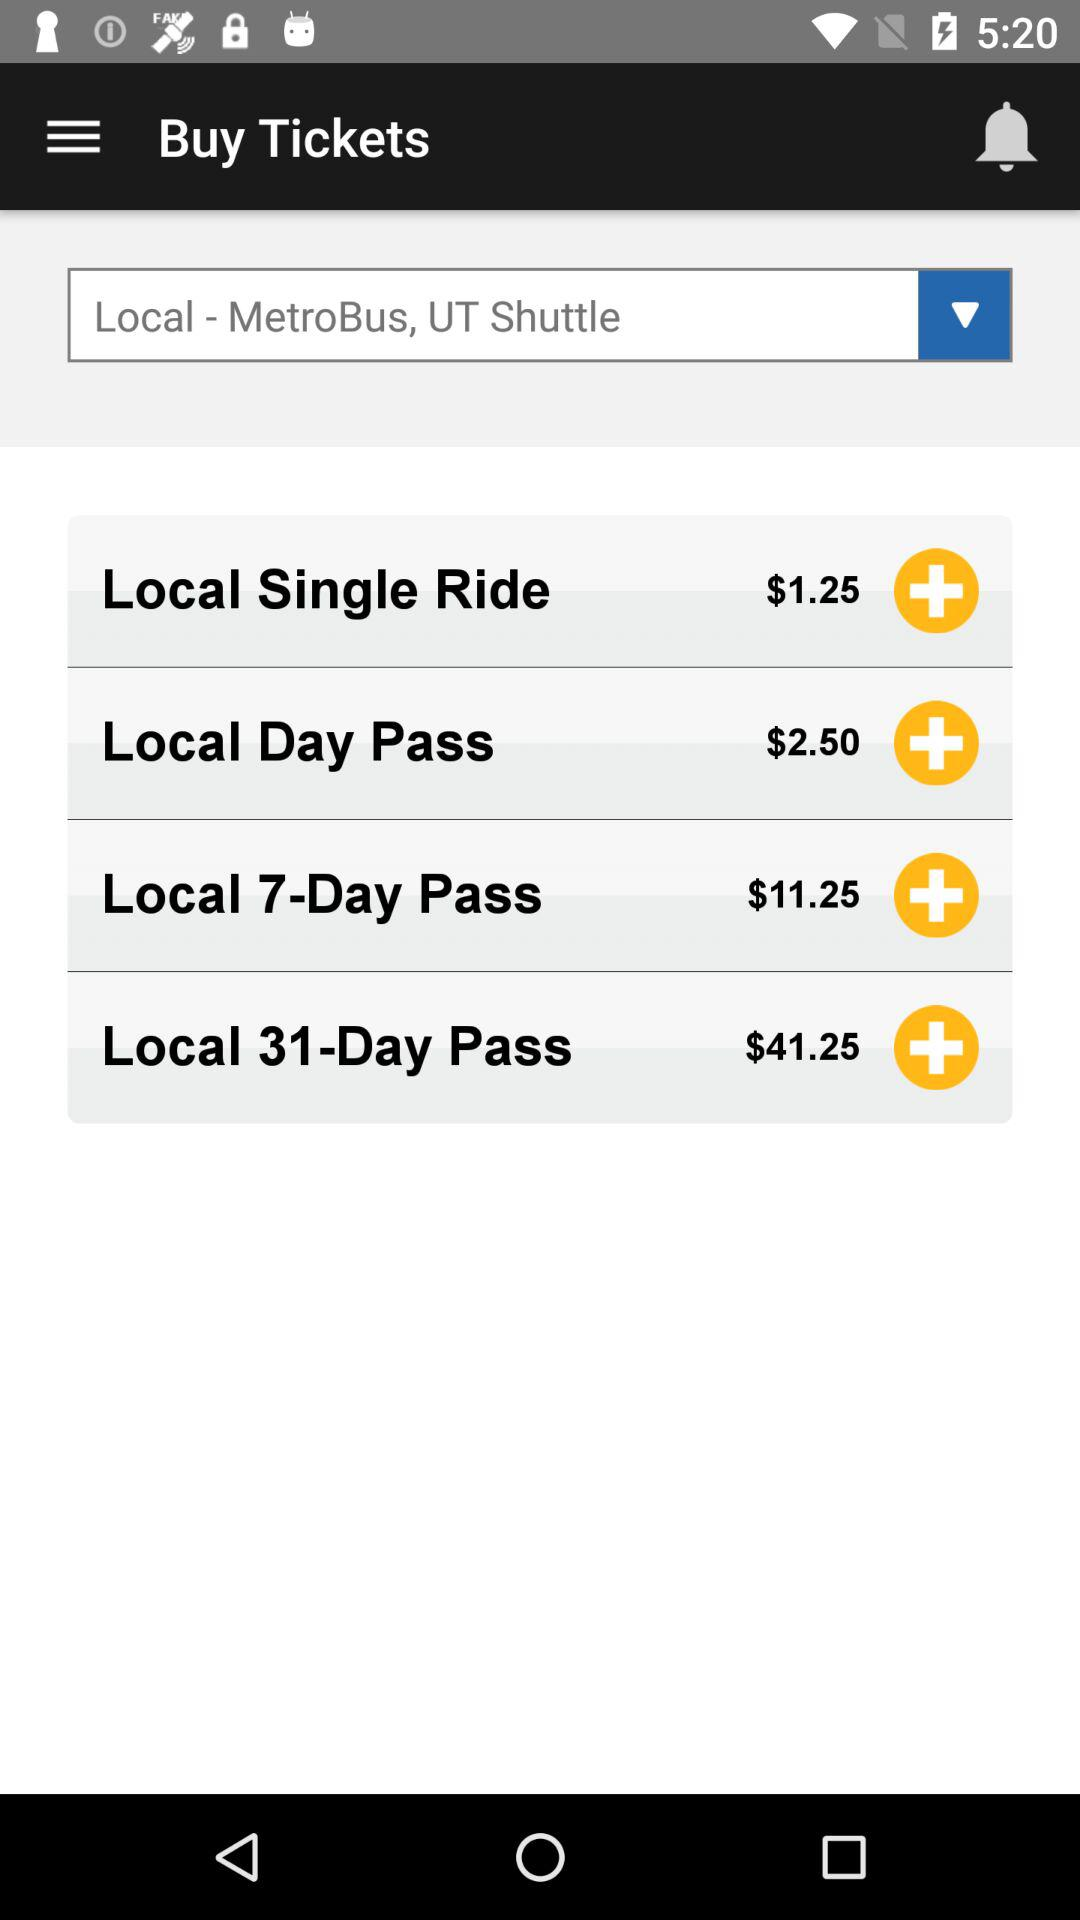How many days is the pass for at $41.25? It is for 7 days. 